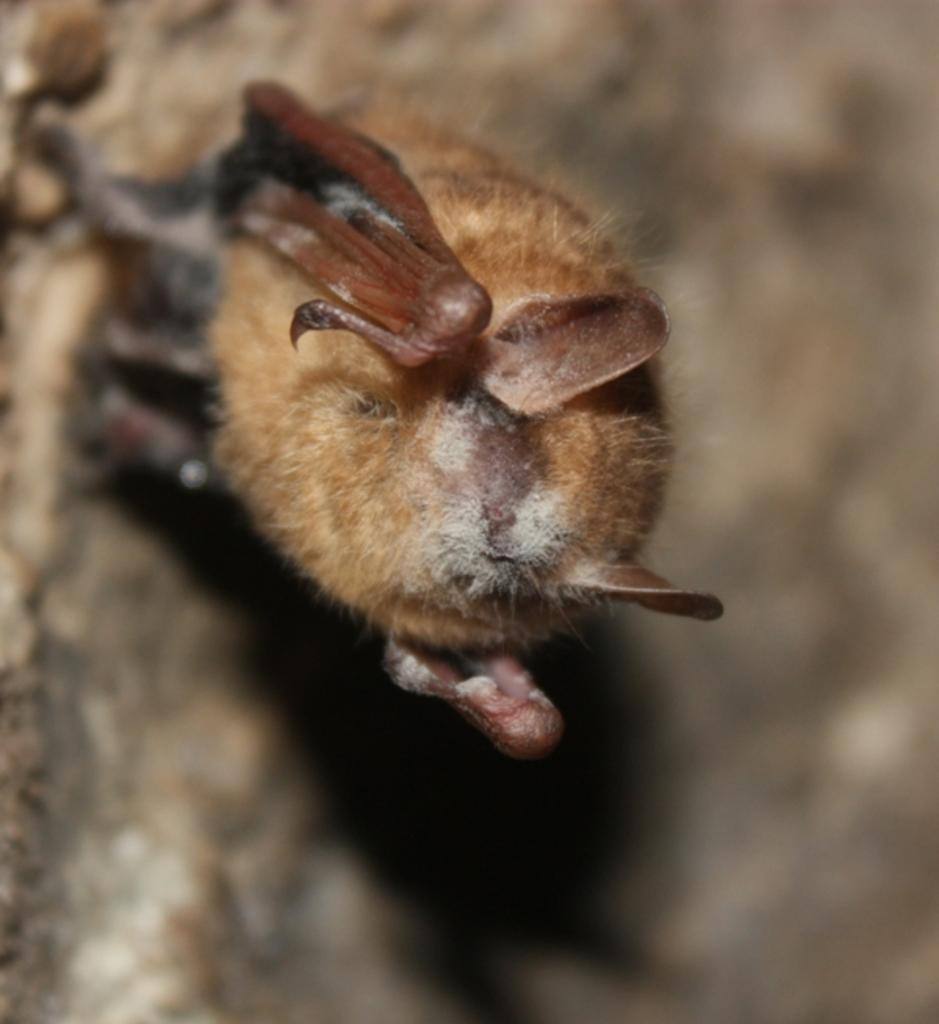What animal is present in the image? There is a bat in the image. Can you describe the background of the image? The background of the image is blurred. What type of trade is being conducted in the image? There is no trade being conducted in the image; it features a bat and a blurred background. What is the father doing in the image? There is no father present in the image; it only features a bat and a blurred background. 